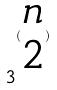Convert formula to latex. <formula><loc_0><loc_0><loc_500><loc_500>3 ^ { ( \begin{matrix} n \\ 2 \end{matrix} ) }</formula> 